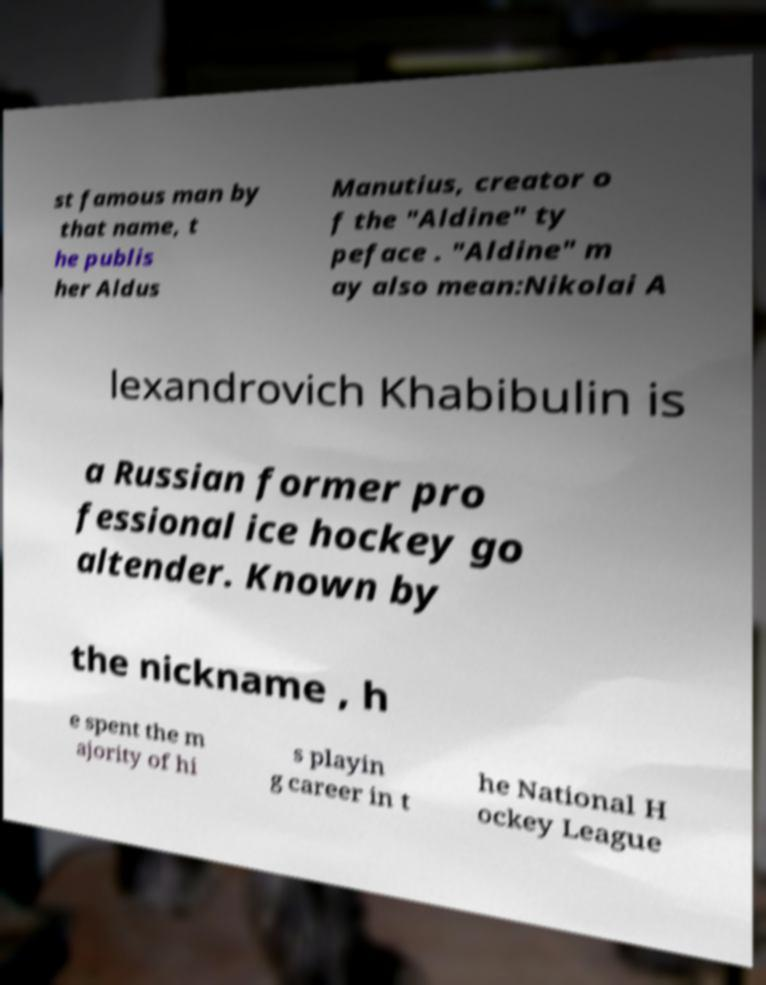I need the written content from this picture converted into text. Can you do that? st famous man by that name, t he publis her Aldus Manutius, creator o f the "Aldine" ty peface . "Aldine" m ay also mean:Nikolai A lexandrovich Khabibulin is a Russian former pro fessional ice hockey go altender. Known by the nickname , h e spent the m ajority of hi s playin g career in t he National H ockey League 